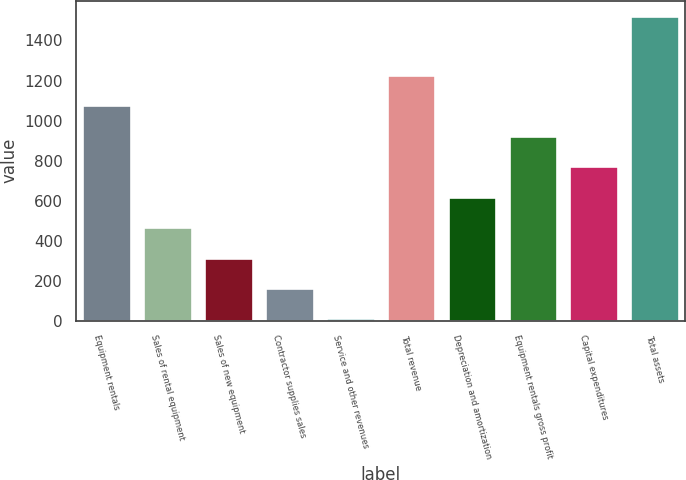Convert chart to OTSL. <chart><loc_0><loc_0><loc_500><loc_500><bar_chart><fcel>Equipment rentals<fcel>Sales of rental equipment<fcel>Sales of new equipment<fcel>Contractor supplies sales<fcel>Service and other revenues<fcel>Total revenue<fcel>Depreciation and amortization<fcel>Equipment rentals gross profit<fcel>Capital expenditures<fcel>Total assets<nl><fcel>1075.7<fcel>467.3<fcel>315.2<fcel>163.1<fcel>11<fcel>1227.8<fcel>619.4<fcel>923.6<fcel>771.5<fcel>1522<nl></chart> 